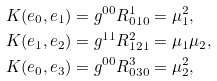Convert formula to latex. <formula><loc_0><loc_0><loc_500><loc_500>K ( e _ { 0 } , e _ { 1 } ) & = g ^ { 0 0 } R ^ { 1 } _ { 0 1 0 } = \mu _ { 1 } ^ { 2 } , \\ K ( e _ { 1 } , e _ { 2 } ) & = g ^ { 1 1 } R ^ { 2 } _ { 1 2 1 } = \mu _ { 1 } \mu _ { 2 } , \\ K ( e _ { 0 } , e _ { 3 } ) & = g ^ { 0 0 } R ^ { 3 } _ { 0 3 0 } = \mu _ { 2 } ^ { 2 } ,</formula> 